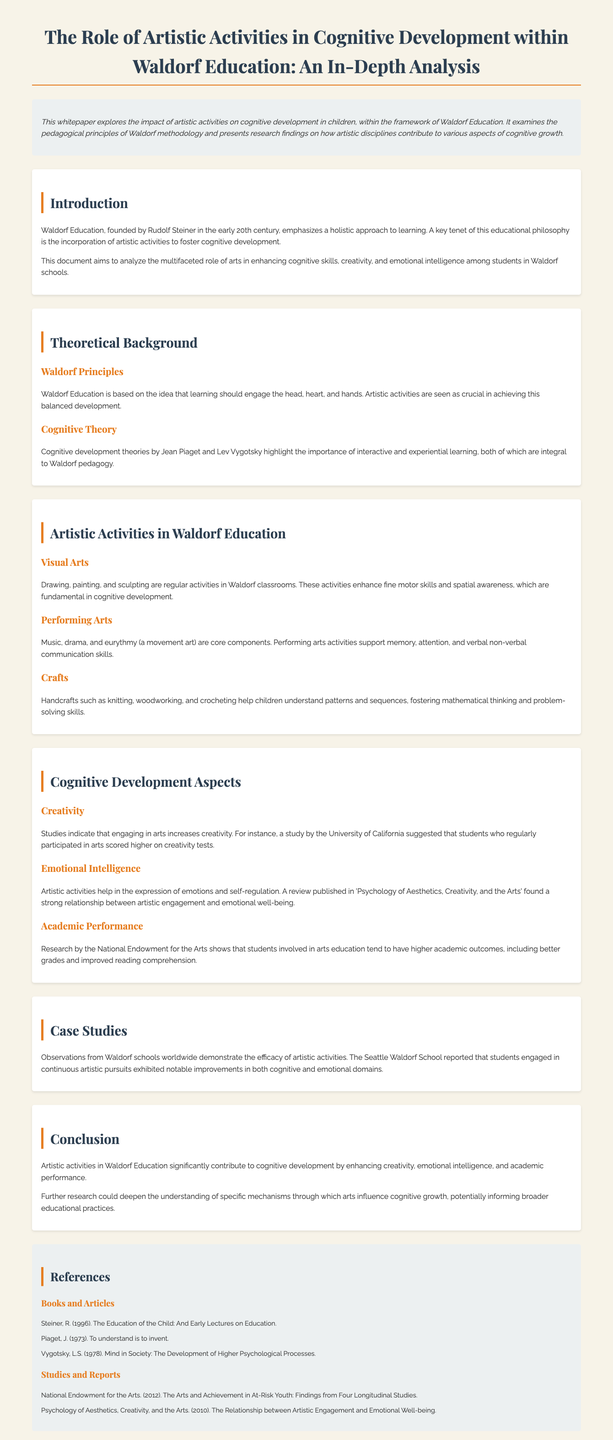What is the main focus of the whitepaper? The main focus of the whitepaper is the impact of artistic activities on cognitive development in children within the framework of Waldorf Education.
Answer: Impact of artistic activities on cognitive development Who founded Waldorf Education? Waldorf Education was founded by Rudolf Steiner in the early 20th century.
Answer: Rudolf Steiner What are the three elements engaged in Waldorf Education? The three elements are the head, heart, and hands.
Answer: Head, heart, and hands Which artistic activity is mentioned as enhancing fine motor skills? Drawing, painting, and sculpting are mentioned as enhancing fine motor skills.
Answer: Drawing, painting, and sculpting What cognitive aspect does engaging in arts increase according to studies? Engaging in arts increases creativity.
Answer: Creativity Which report shows a relationship between arts education and academic outcomes? The report by the National Endowment for the Arts shows this relationship.
Answer: National Endowment for the Arts What is the effectiveness of artistic activities demonstrated through? The effectiveness is demonstrated through observations from Waldorf schools worldwide.
Answer: Observations from Waldorf schools What additional area could benefit from further research according to the conclusion? Further research could deepen the understanding of specific mechanisms through which arts influence cognitive growth.
Answer: Specific mechanisms of arts influence on cognitive growth 